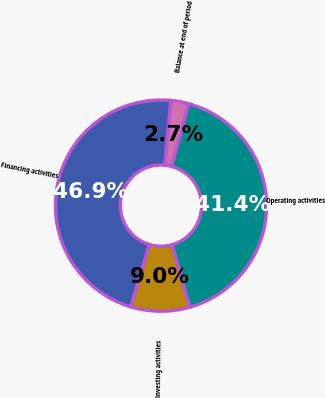Convert chart to OTSL. <chart><loc_0><loc_0><loc_500><loc_500><pie_chart><fcel>Operating activities<fcel>Investing activities<fcel>Financing activities<fcel>Balance at end of period<nl><fcel>41.44%<fcel>9.01%<fcel>46.85%<fcel>2.7%<nl></chart> 